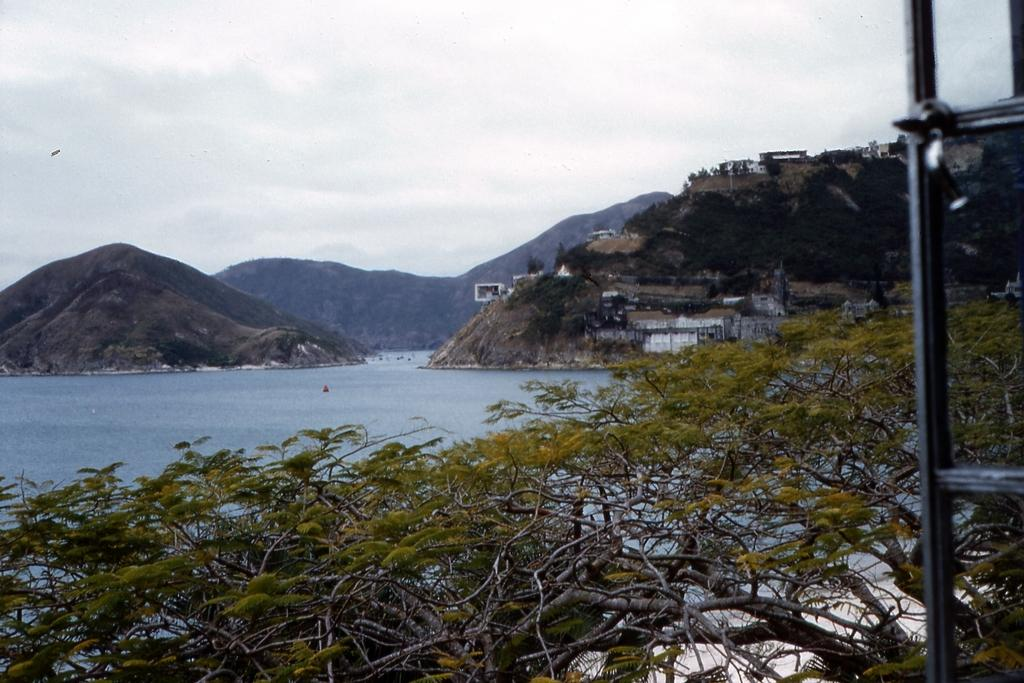What type of natural landscape can be seen in the image? There are hills in the image. What is visible in the image besides the hills? There is water and trees visible in the image. Are there any man-made structures present in the image? Yes, there are houses on the hill in the image. What is the condition of the sky in the image? The sky is cloudy in the image. What type of channel can be seen running through the cushion in the image? There is no channel or cushion present in the image. 